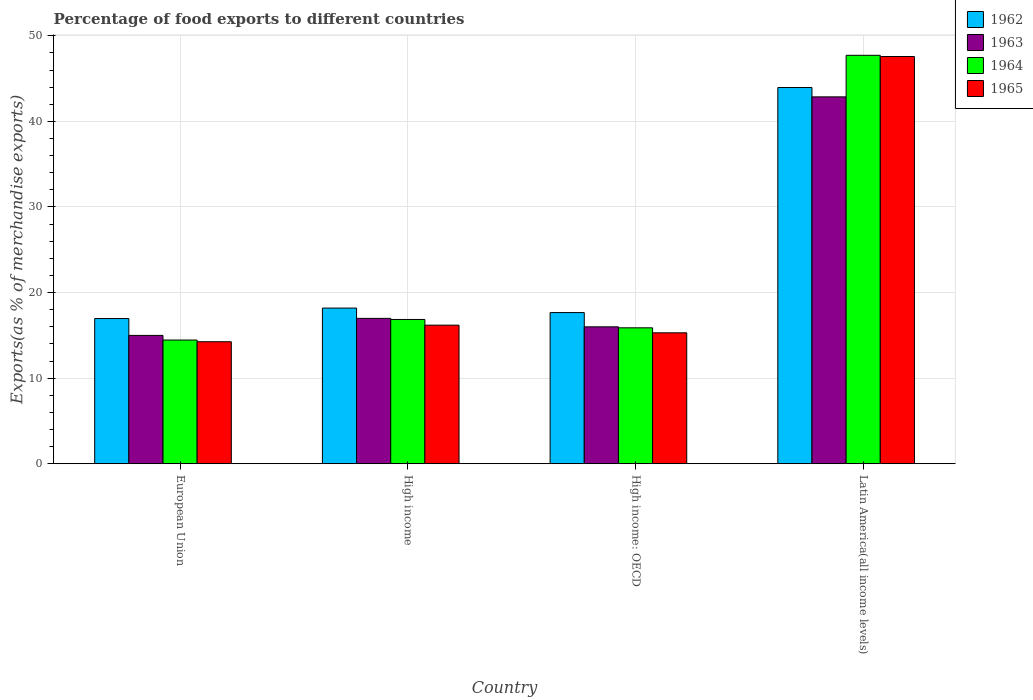How many groups of bars are there?
Make the answer very short. 4. How many bars are there on the 3rd tick from the right?
Your response must be concise. 4. In how many cases, is the number of bars for a given country not equal to the number of legend labels?
Your answer should be very brief. 0. What is the percentage of exports to different countries in 1962 in European Union?
Offer a terse response. 16.96. Across all countries, what is the maximum percentage of exports to different countries in 1963?
Ensure brevity in your answer.  42.86. Across all countries, what is the minimum percentage of exports to different countries in 1963?
Offer a very short reply. 14.99. In which country was the percentage of exports to different countries in 1962 maximum?
Keep it short and to the point. Latin America(all income levels). What is the total percentage of exports to different countries in 1963 in the graph?
Your answer should be compact. 90.84. What is the difference between the percentage of exports to different countries in 1964 in High income and that in Latin America(all income levels)?
Make the answer very short. -30.86. What is the difference between the percentage of exports to different countries in 1965 in High income and the percentage of exports to different countries in 1962 in High income: OECD?
Your answer should be very brief. -1.47. What is the average percentage of exports to different countries in 1963 per country?
Offer a terse response. 22.71. What is the difference between the percentage of exports to different countries of/in 1964 and percentage of exports to different countries of/in 1963 in European Union?
Give a very brief answer. -0.54. In how many countries, is the percentage of exports to different countries in 1962 greater than 14 %?
Give a very brief answer. 4. What is the ratio of the percentage of exports to different countries in 1963 in European Union to that in High income: OECD?
Provide a short and direct response. 0.94. What is the difference between the highest and the second highest percentage of exports to different countries in 1964?
Make the answer very short. 0.98. What is the difference between the highest and the lowest percentage of exports to different countries in 1963?
Your answer should be compact. 27.87. In how many countries, is the percentage of exports to different countries in 1964 greater than the average percentage of exports to different countries in 1964 taken over all countries?
Provide a short and direct response. 1. Is the sum of the percentage of exports to different countries in 1962 in High income: OECD and Latin America(all income levels) greater than the maximum percentage of exports to different countries in 1963 across all countries?
Your response must be concise. Yes. What does the 3rd bar from the left in High income represents?
Ensure brevity in your answer.  1964. What does the 1st bar from the right in Latin America(all income levels) represents?
Make the answer very short. 1965. Are all the bars in the graph horizontal?
Give a very brief answer. No. How many countries are there in the graph?
Offer a very short reply. 4. Are the values on the major ticks of Y-axis written in scientific E-notation?
Your answer should be very brief. No. Does the graph contain any zero values?
Your response must be concise. No. Where does the legend appear in the graph?
Offer a very short reply. Top right. What is the title of the graph?
Your answer should be very brief. Percentage of food exports to different countries. Does "2000" appear as one of the legend labels in the graph?
Your answer should be compact. No. What is the label or title of the X-axis?
Your answer should be very brief. Country. What is the label or title of the Y-axis?
Your answer should be very brief. Exports(as % of merchandise exports). What is the Exports(as % of merchandise exports) in 1962 in European Union?
Your answer should be very brief. 16.96. What is the Exports(as % of merchandise exports) of 1963 in European Union?
Your answer should be very brief. 14.99. What is the Exports(as % of merchandise exports) in 1964 in European Union?
Your answer should be compact. 14.45. What is the Exports(as % of merchandise exports) in 1965 in European Union?
Provide a short and direct response. 14.25. What is the Exports(as % of merchandise exports) in 1962 in High income?
Provide a succinct answer. 18.19. What is the Exports(as % of merchandise exports) of 1963 in High income?
Provide a succinct answer. 16.98. What is the Exports(as % of merchandise exports) of 1964 in High income?
Your answer should be very brief. 16.86. What is the Exports(as % of merchandise exports) in 1965 in High income?
Provide a short and direct response. 16.19. What is the Exports(as % of merchandise exports) of 1962 in High income: OECD?
Provide a succinct answer. 17.66. What is the Exports(as % of merchandise exports) of 1963 in High income: OECD?
Offer a terse response. 16. What is the Exports(as % of merchandise exports) of 1964 in High income: OECD?
Ensure brevity in your answer.  15.88. What is the Exports(as % of merchandise exports) in 1965 in High income: OECD?
Ensure brevity in your answer.  15.3. What is the Exports(as % of merchandise exports) of 1962 in Latin America(all income levels)?
Keep it short and to the point. 43.96. What is the Exports(as % of merchandise exports) in 1963 in Latin America(all income levels)?
Provide a succinct answer. 42.86. What is the Exports(as % of merchandise exports) in 1964 in Latin America(all income levels)?
Make the answer very short. 47.72. What is the Exports(as % of merchandise exports) in 1965 in Latin America(all income levels)?
Ensure brevity in your answer.  47.58. Across all countries, what is the maximum Exports(as % of merchandise exports) of 1962?
Make the answer very short. 43.96. Across all countries, what is the maximum Exports(as % of merchandise exports) of 1963?
Give a very brief answer. 42.86. Across all countries, what is the maximum Exports(as % of merchandise exports) in 1964?
Ensure brevity in your answer.  47.72. Across all countries, what is the maximum Exports(as % of merchandise exports) in 1965?
Provide a short and direct response. 47.58. Across all countries, what is the minimum Exports(as % of merchandise exports) of 1962?
Your answer should be compact. 16.96. Across all countries, what is the minimum Exports(as % of merchandise exports) of 1963?
Your answer should be very brief. 14.99. Across all countries, what is the minimum Exports(as % of merchandise exports) of 1964?
Provide a short and direct response. 14.45. Across all countries, what is the minimum Exports(as % of merchandise exports) in 1965?
Provide a succinct answer. 14.25. What is the total Exports(as % of merchandise exports) of 1962 in the graph?
Your answer should be very brief. 96.77. What is the total Exports(as % of merchandise exports) in 1963 in the graph?
Offer a very short reply. 90.84. What is the total Exports(as % of merchandise exports) in 1964 in the graph?
Make the answer very short. 94.91. What is the total Exports(as % of merchandise exports) in 1965 in the graph?
Your answer should be compact. 93.32. What is the difference between the Exports(as % of merchandise exports) of 1962 in European Union and that in High income?
Your answer should be compact. -1.22. What is the difference between the Exports(as % of merchandise exports) of 1963 in European Union and that in High income?
Offer a terse response. -1.99. What is the difference between the Exports(as % of merchandise exports) of 1964 in European Union and that in High income?
Your answer should be very brief. -2.4. What is the difference between the Exports(as % of merchandise exports) in 1965 in European Union and that in High income?
Keep it short and to the point. -1.94. What is the difference between the Exports(as % of merchandise exports) in 1962 in European Union and that in High income: OECD?
Your response must be concise. -0.7. What is the difference between the Exports(as % of merchandise exports) in 1963 in European Union and that in High income: OECD?
Give a very brief answer. -1. What is the difference between the Exports(as % of merchandise exports) in 1964 in European Union and that in High income: OECD?
Offer a terse response. -1.43. What is the difference between the Exports(as % of merchandise exports) of 1965 in European Union and that in High income: OECD?
Your answer should be compact. -1.04. What is the difference between the Exports(as % of merchandise exports) of 1962 in European Union and that in Latin America(all income levels)?
Offer a terse response. -26.99. What is the difference between the Exports(as % of merchandise exports) in 1963 in European Union and that in Latin America(all income levels)?
Provide a succinct answer. -27.87. What is the difference between the Exports(as % of merchandise exports) of 1964 in European Union and that in Latin America(all income levels)?
Give a very brief answer. -33.27. What is the difference between the Exports(as % of merchandise exports) of 1965 in European Union and that in Latin America(all income levels)?
Offer a terse response. -33.32. What is the difference between the Exports(as % of merchandise exports) of 1962 in High income and that in High income: OECD?
Provide a succinct answer. 0.53. What is the difference between the Exports(as % of merchandise exports) in 1964 in High income and that in High income: OECD?
Your answer should be very brief. 0.98. What is the difference between the Exports(as % of merchandise exports) in 1965 in High income and that in High income: OECD?
Provide a short and direct response. 0.89. What is the difference between the Exports(as % of merchandise exports) in 1962 in High income and that in Latin America(all income levels)?
Ensure brevity in your answer.  -25.77. What is the difference between the Exports(as % of merchandise exports) in 1963 in High income and that in Latin America(all income levels)?
Your answer should be compact. -25.88. What is the difference between the Exports(as % of merchandise exports) of 1964 in High income and that in Latin America(all income levels)?
Your answer should be compact. -30.86. What is the difference between the Exports(as % of merchandise exports) of 1965 in High income and that in Latin America(all income levels)?
Make the answer very short. -31.39. What is the difference between the Exports(as % of merchandise exports) of 1962 in High income: OECD and that in Latin America(all income levels)?
Your response must be concise. -26.3. What is the difference between the Exports(as % of merchandise exports) in 1963 in High income: OECD and that in Latin America(all income levels)?
Your response must be concise. -26.87. What is the difference between the Exports(as % of merchandise exports) in 1964 in High income: OECD and that in Latin America(all income levels)?
Keep it short and to the point. -31.84. What is the difference between the Exports(as % of merchandise exports) in 1965 in High income: OECD and that in Latin America(all income levels)?
Ensure brevity in your answer.  -32.28. What is the difference between the Exports(as % of merchandise exports) in 1962 in European Union and the Exports(as % of merchandise exports) in 1963 in High income?
Offer a very short reply. -0.02. What is the difference between the Exports(as % of merchandise exports) of 1962 in European Union and the Exports(as % of merchandise exports) of 1964 in High income?
Your response must be concise. 0.11. What is the difference between the Exports(as % of merchandise exports) of 1962 in European Union and the Exports(as % of merchandise exports) of 1965 in High income?
Ensure brevity in your answer.  0.77. What is the difference between the Exports(as % of merchandise exports) of 1963 in European Union and the Exports(as % of merchandise exports) of 1964 in High income?
Your answer should be very brief. -1.86. What is the difference between the Exports(as % of merchandise exports) of 1963 in European Union and the Exports(as % of merchandise exports) of 1965 in High income?
Your answer should be very brief. -1.2. What is the difference between the Exports(as % of merchandise exports) in 1964 in European Union and the Exports(as % of merchandise exports) in 1965 in High income?
Provide a succinct answer. -1.74. What is the difference between the Exports(as % of merchandise exports) of 1962 in European Union and the Exports(as % of merchandise exports) of 1963 in High income: OECD?
Your response must be concise. 0.97. What is the difference between the Exports(as % of merchandise exports) of 1962 in European Union and the Exports(as % of merchandise exports) of 1964 in High income: OECD?
Give a very brief answer. 1.08. What is the difference between the Exports(as % of merchandise exports) in 1962 in European Union and the Exports(as % of merchandise exports) in 1965 in High income: OECD?
Offer a terse response. 1.67. What is the difference between the Exports(as % of merchandise exports) in 1963 in European Union and the Exports(as % of merchandise exports) in 1964 in High income: OECD?
Offer a terse response. -0.89. What is the difference between the Exports(as % of merchandise exports) of 1963 in European Union and the Exports(as % of merchandise exports) of 1965 in High income: OECD?
Provide a short and direct response. -0.3. What is the difference between the Exports(as % of merchandise exports) of 1964 in European Union and the Exports(as % of merchandise exports) of 1965 in High income: OECD?
Your response must be concise. -0.84. What is the difference between the Exports(as % of merchandise exports) in 1962 in European Union and the Exports(as % of merchandise exports) in 1963 in Latin America(all income levels)?
Your answer should be compact. -25.9. What is the difference between the Exports(as % of merchandise exports) in 1962 in European Union and the Exports(as % of merchandise exports) in 1964 in Latin America(all income levels)?
Give a very brief answer. -30.76. What is the difference between the Exports(as % of merchandise exports) of 1962 in European Union and the Exports(as % of merchandise exports) of 1965 in Latin America(all income levels)?
Offer a very short reply. -30.61. What is the difference between the Exports(as % of merchandise exports) in 1963 in European Union and the Exports(as % of merchandise exports) in 1964 in Latin America(all income levels)?
Make the answer very short. -32.73. What is the difference between the Exports(as % of merchandise exports) in 1963 in European Union and the Exports(as % of merchandise exports) in 1965 in Latin America(all income levels)?
Make the answer very short. -32.58. What is the difference between the Exports(as % of merchandise exports) in 1964 in European Union and the Exports(as % of merchandise exports) in 1965 in Latin America(all income levels)?
Provide a short and direct response. -33.12. What is the difference between the Exports(as % of merchandise exports) of 1962 in High income and the Exports(as % of merchandise exports) of 1963 in High income: OECD?
Provide a succinct answer. 2.19. What is the difference between the Exports(as % of merchandise exports) in 1962 in High income and the Exports(as % of merchandise exports) in 1964 in High income: OECD?
Keep it short and to the point. 2.31. What is the difference between the Exports(as % of merchandise exports) of 1962 in High income and the Exports(as % of merchandise exports) of 1965 in High income: OECD?
Offer a terse response. 2.89. What is the difference between the Exports(as % of merchandise exports) of 1963 in High income and the Exports(as % of merchandise exports) of 1964 in High income: OECD?
Keep it short and to the point. 1.1. What is the difference between the Exports(as % of merchandise exports) in 1963 in High income and the Exports(as % of merchandise exports) in 1965 in High income: OECD?
Offer a very short reply. 1.69. What is the difference between the Exports(as % of merchandise exports) in 1964 in High income and the Exports(as % of merchandise exports) in 1965 in High income: OECD?
Your response must be concise. 1.56. What is the difference between the Exports(as % of merchandise exports) in 1962 in High income and the Exports(as % of merchandise exports) in 1963 in Latin America(all income levels)?
Offer a very short reply. -24.68. What is the difference between the Exports(as % of merchandise exports) of 1962 in High income and the Exports(as % of merchandise exports) of 1964 in Latin America(all income levels)?
Offer a very short reply. -29.53. What is the difference between the Exports(as % of merchandise exports) in 1962 in High income and the Exports(as % of merchandise exports) in 1965 in Latin America(all income levels)?
Offer a very short reply. -29.39. What is the difference between the Exports(as % of merchandise exports) of 1963 in High income and the Exports(as % of merchandise exports) of 1964 in Latin America(all income levels)?
Keep it short and to the point. -30.74. What is the difference between the Exports(as % of merchandise exports) of 1963 in High income and the Exports(as % of merchandise exports) of 1965 in Latin America(all income levels)?
Make the answer very short. -30.59. What is the difference between the Exports(as % of merchandise exports) in 1964 in High income and the Exports(as % of merchandise exports) in 1965 in Latin America(all income levels)?
Your answer should be compact. -30.72. What is the difference between the Exports(as % of merchandise exports) of 1962 in High income: OECD and the Exports(as % of merchandise exports) of 1963 in Latin America(all income levels)?
Give a very brief answer. -25.2. What is the difference between the Exports(as % of merchandise exports) of 1962 in High income: OECD and the Exports(as % of merchandise exports) of 1964 in Latin America(all income levels)?
Your answer should be very brief. -30.06. What is the difference between the Exports(as % of merchandise exports) in 1962 in High income: OECD and the Exports(as % of merchandise exports) in 1965 in Latin America(all income levels)?
Provide a succinct answer. -29.92. What is the difference between the Exports(as % of merchandise exports) in 1963 in High income: OECD and the Exports(as % of merchandise exports) in 1964 in Latin America(all income levels)?
Provide a succinct answer. -31.73. What is the difference between the Exports(as % of merchandise exports) in 1963 in High income: OECD and the Exports(as % of merchandise exports) in 1965 in Latin America(all income levels)?
Offer a very short reply. -31.58. What is the difference between the Exports(as % of merchandise exports) of 1964 in High income: OECD and the Exports(as % of merchandise exports) of 1965 in Latin America(all income levels)?
Ensure brevity in your answer.  -31.7. What is the average Exports(as % of merchandise exports) in 1962 per country?
Make the answer very short. 24.19. What is the average Exports(as % of merchandise exports) of 1963 per country?
Offer a very short reply. 22.71. What is the average Exports(as % of merchandise exports) in 1964 per country?
Your answer should be very brief. 23.73. What is the average Exports(as % of merchandise exports) in 1965 per country?
Keep it short and to the point. 23.33. What is the difference between the Exports(as % of merchandise exports) of 1962 and Exports(as % of merchandise exports) of 1963 in European Union?
Your response must be concise. 1.97. What is the difference between the Exports(as % of merchandise exports) in 1962 and Exports(as % of merchandise exports) in 1964 in European Union?
Make the answer very short. 2.51. What is the difference between the Exports(as % of merchandise exports) of 1962 and Exports(as % of merchandise exports) of 1965 in European Union?
Your answer should be very brief. 2.71. What is the difference between the Exports(as % of merchandise exports) of 1963 and Exports(as % of merchandise exports) of 1964 in European Union?
Offer a terse response. 0.54. What is the difference between the Exports(as % of merchandise exports) in 1963 and Exports(as % of merchandise exports) in 1965 in European Union?
Your response must be concise. 0.74. What is the difference between the Exports(as % of merchandise exports) of 1964 and Exports(as % of merchandise exports) of 1965 in European Union?
Make the answer very short. 0.2. What is the difference between the Exports(as % of merchandise exports) in 1962 and Exports(as % of merchandise exports) in 1963 in High income?
Your answer should be compact. 1.2. What is the difference between the Exports(as % of merchandise exports) in 1962 and Exports(as % of merchandise exports) in 1964 in High income?
Your response must be concise. 1.33. What is the difference between the Exports(as % of merchandise exports) of 1962 and Exports(as % of merchandise exports) of 1965 in High income?
Keep it short and to the point. 2. What is the difference between the Exports(as % of merchandise exports) in 1963 and Exports(as % of merchandise exports) in 1964 in High income?
Your answer should be compact. 0.13. What is the difference between the Exports(as % of merchandise exports) of 1963 and Exports(as % of merchandise exports) of 1965 in High income?
Provide a succinct answer. 0.79. What is the difference between the Exports(as % of merchandise exports) in 1964 and Exports(as % of merchandise exports) in 1965 in High income?
Keep it short and to the point. 0.67. What is the difference between the Exports(as % of merchandise exports) of 1962 and Exports(as % of merchandise exports) of 1963 in High income: OECD?
Give a very brief answer. 1.66. What is the difference between the Exports(as % of merchandise exports) of 1962 and Exports(as % of merchandise exports) of 1964 in High income: OECD?
Offer a terse response. 1.78. What is the difference between the Exports(as % of merchandise exports) of 1962 and Exports(as % of merchandise exports) of 1965 in High income: OECD?
Make the answer very short. 2.36. What is the difference between the Exports(as % of merchandise exports) of 1963 and Exports(as % of merchandise exports) of 1964 in High income: OECD?
Ensure brevity in your answer.  0.12. What is the difference between the Exports(as % of merchandise exports) of 1963 and Exports(as % of merchandise exports) of 1965 in High income: OECD?
Make the answer very short. 0.7. What is the difference between the Exports(as % of merchandise exports) in 1964 and Exports(as % of merchandise exports) in 1965 in High income: OECD?
Ensure brevity in your answer.  0.58. What is the difference between the Exports(as % of merchandise exports) in 1962 and Exports(as % of merchandise exports) in 1963 in Latin America(all income levels)?
Make the answer very short. 1.09. What is the difference between the Exports(as % of merchandise exports) in 1962 and Exports(as % of merchandise exports) in 1964 in Latin America(all income levels)?
Your answer should be compact. -3.77. What is the difference between the Exports(as % of merchandise exports) in 1962 and Exports(as % of merchandise exports) in 1965 in Latin America(all income levels)?
Give a very brief answer. -3.62. What is the difference between the Exports(as % of merchandise exports) in 1963 and Exports(as % of merchandise exports) in 1964 in Latin America(all income levels)?
Provide a short and direct response. -4.86. What is the difference between the Exports(as % of merchandise exports) of 1963 and Exports(as % of merchandise exports) of 1965 in Latin America(all income levels)?
Give a very brief answer. -4.71. What is the difference between the Exports(as % of merchandise exports) in 1964 and Exports(as % of merchandise exports) in 1965 in Latin America(all income levels)?
Your answer should be very brief. 0.14. What is the ratio of the Exports(as % of merchandise exports) in 1962 in European Union to that in High income?
Provide a succinct answer. 0.93. What is the ratio of the Exports(as % of merchandise exports) of 1963 in European Union to that in High income?
Provide a short and direct response. 0.88. What is the ratio of the Exports(as % of merchandise exports) of 1964 in European Union to that in High income?
Your answer should be compact. 0.86. What is the ratio of the Exports(as % of merchandise exports) of 1965 in European Union to that in High income?
Make the answer very short. 0.88. What is the ratio of the Exports(as % of merchandise exports) of 1962 in European Union to that in High income: OECD?
Your answer should be compact. 0.96. What is the ratio of the Exports(as % of merchandise exports) of 1963 in European Union to that in High income: OECD?
Offer a terse response. 0.94. What is the ratio of the Exports(as % of merchandise exports) of 1964 in European Union to that in High income: OECD?
Ensure brevity in your answer.  0.91. What is the ratio of the Exports(as % of merchandise exports) of 1965 in European Union to that in High income: OECD?
Give a very brief answer. 0.93. What is the ratio of the Exports(as % of merchandise exports) of 1962 in European Union to that in Latin America(all income levels)?
Offer a terse response. 0.39. What is the ratio of the Exports(as % of merchandise exports) in 1963 in European Union to that in Latin America(all income levels)?
Provide a succinct answer. 0.35. What is the ratio of the Exports(as % of merchandise exports) in 1964 in European Union to that in Latin America(all income levels)?
Ensure brevity in your answer.  0.3. What is the ratio of the Exports(as % of merchandise exports) of 1965 in European Union to that in Latin America(all income levels)?
Your response must be concise. 0.3. What is the ratio of the Exports(as % of merchandise exports) in 1962 in High income to that in High income: OECD?
Provide a short and direct response. 1.03. What is the ratio of the Exports(as % of merchandise exports) of 1963 in High income to that in High income: OECD?
Ensure brevity in your answer.  1.06. What is the ratio of the Exports(as % of merchandise exports) of 1964 in High income to that in High income: OECD?
Ensure brevity in your answer.  1.06. What is the ratio of the Exports(as % of merchandise exports) of 1965 in High income to that in High income: OECD?
Ensure brevity in your answer.  1.06. What is the ratio of the Exports(as % of merchandise exports) in 1962 in High income to that in Latin America(all income levels)?
Provide a succinct answer. 0.41. What is the ratio of the Exports(as % of merchandise exports) of 1963 in High income to that in Latin America(all income levels)?
Offer a very short reply. 0.4. What is the ratio of the Exports(as % of merchandise exports) in 1964 in High income to that in Latin America(all income levels)?
Make the answer very short. 0.35. What is the ratio of the Exports(as % of merchandise exports) in 1965 in High income to that in Latin America(all income levels)?
Make the answer very short. 0.34. What is the ratio of the Exports(as % of merchandise exports) in 1962 in High income: OECD to that in Latin America(all income levels)?
Offer a very short reply. 0.4. What is the ratio of the Exports(as % of merchandise exports) of 1963 in High income: OECD to that in Latin America(all income levels)?
Offer a very short reply. 0.37. What is the ratio of the Exports(as % of merchandise exports) in 1964 in High income: OECD to that in Latin America(all income levels)?
Provide a succinct answer. 0.33. What is the ratio of the Exports(as % of merchandise exports) of 1965 in High income: OECD to that in Latin America(all income levels)?
Offer a very short reply. 0.32. What is the difference between the highest and the second highest Exports(as % of merchandise exports) of 1962?
Give a very brief answer. 25.77. What is the difference between the highest and the second highest Exports(as % of merchandise exports) in 1963?
Keep it short and to the point. 25.88. What is the difference between the highest and the second highest Exports(as % of merchandise exports) in 1964?
Provide a short and direct response. 30.86. What is the difference between the highest and the second highest Exports(as % of merchandise exports) in 1965?
Your answer should be very brief. 31.39. What is the difference between the highest and the lowest Exports(as % of merchandise exports) of 1962?
Your response must be concise. 26.99. What is the difference between the highest and the lowest Exports(as % of merchandise exports) in 1963?
Ensure brevity in your answer.  27.87. What is the difference between the highest and the lowest Exports(as % of merchandise exports) of 1964?
Your response must be concise. 33.27. What is the difference between the highest and the lowest Exports(as % of merchandise exports) of 1965?
Provide a succinct answer. 33.32. 